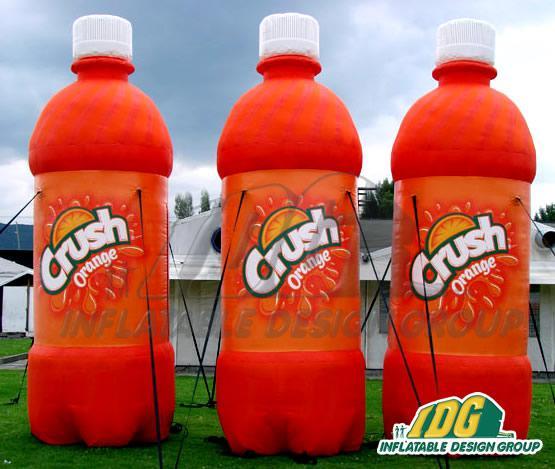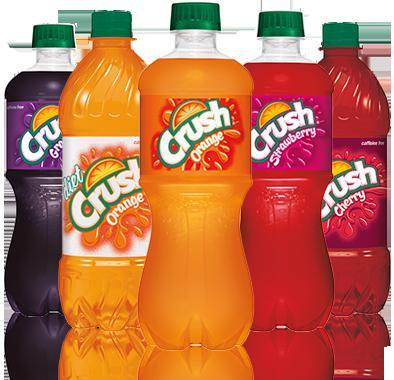The first image is the image on the left, the second image is the image on the right. Examine the images to the left and right. Is the description "In one of the images, all of the bottles are Coca-Cola bottles." accurate? Answer yes or no. No. The first image is the image on the left, the second image is the image on the right. Evaluate the accuracy of this statement regarding the images: "The left image includes at least three metallic-looking, multicolored bottles with red caps in a row, with the middle bottle slightly forward.". Is it true? Answer yes or no. No. 